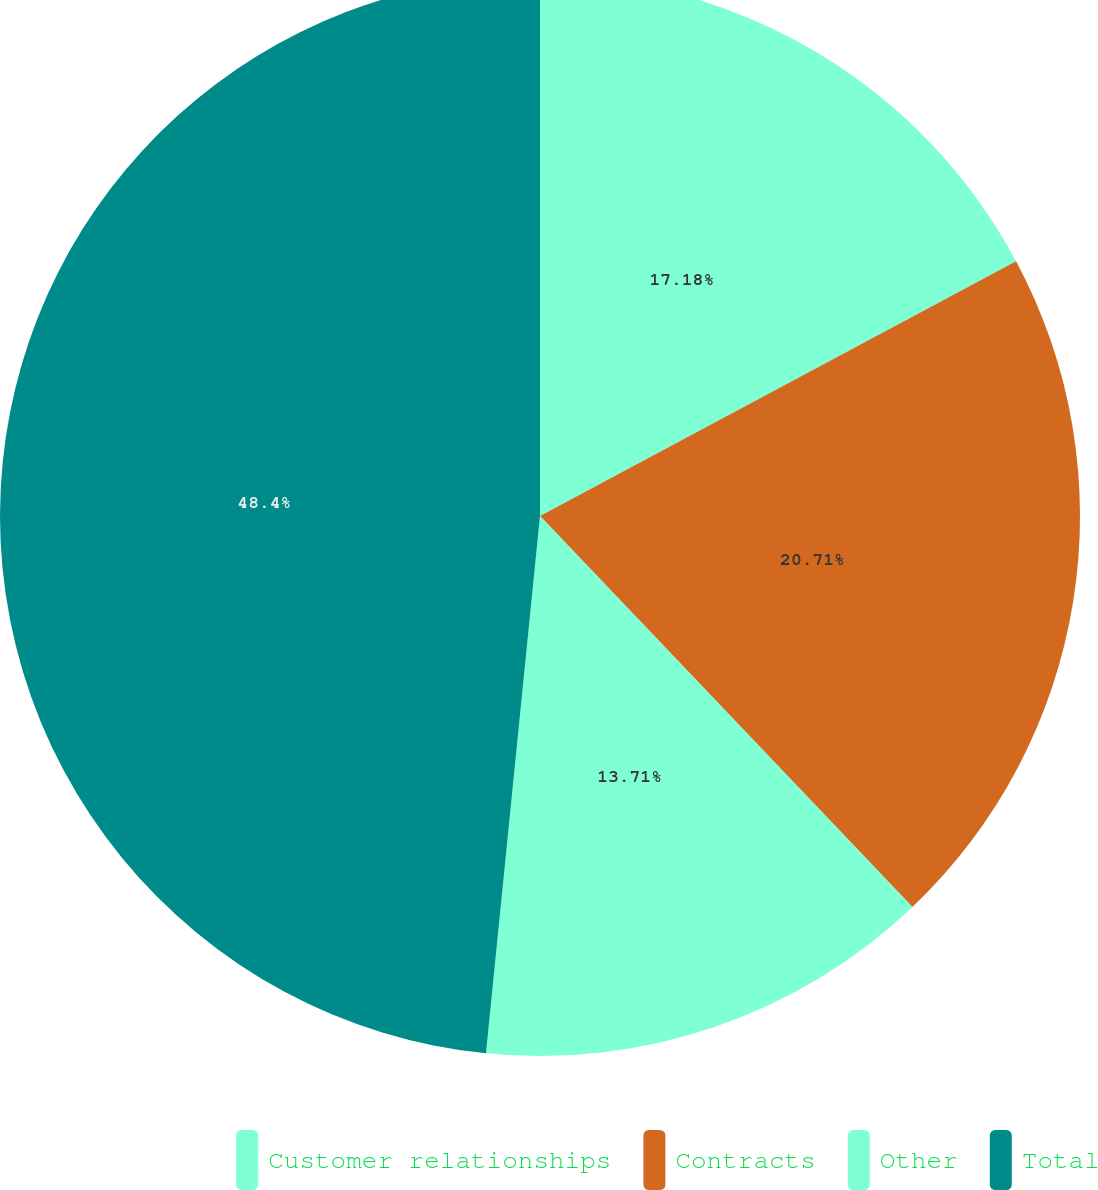Convert chart. <chart><loc_0><loc_0><loc_500><loc_500><pie_chart><fcel>Customer relationships<fcel>Contracts<fcel>Other<fcel>Total<nl><fcel>17.18%<fcel>20.71%<fcel>13.71%<fcel>48.41%<nl></chart> 